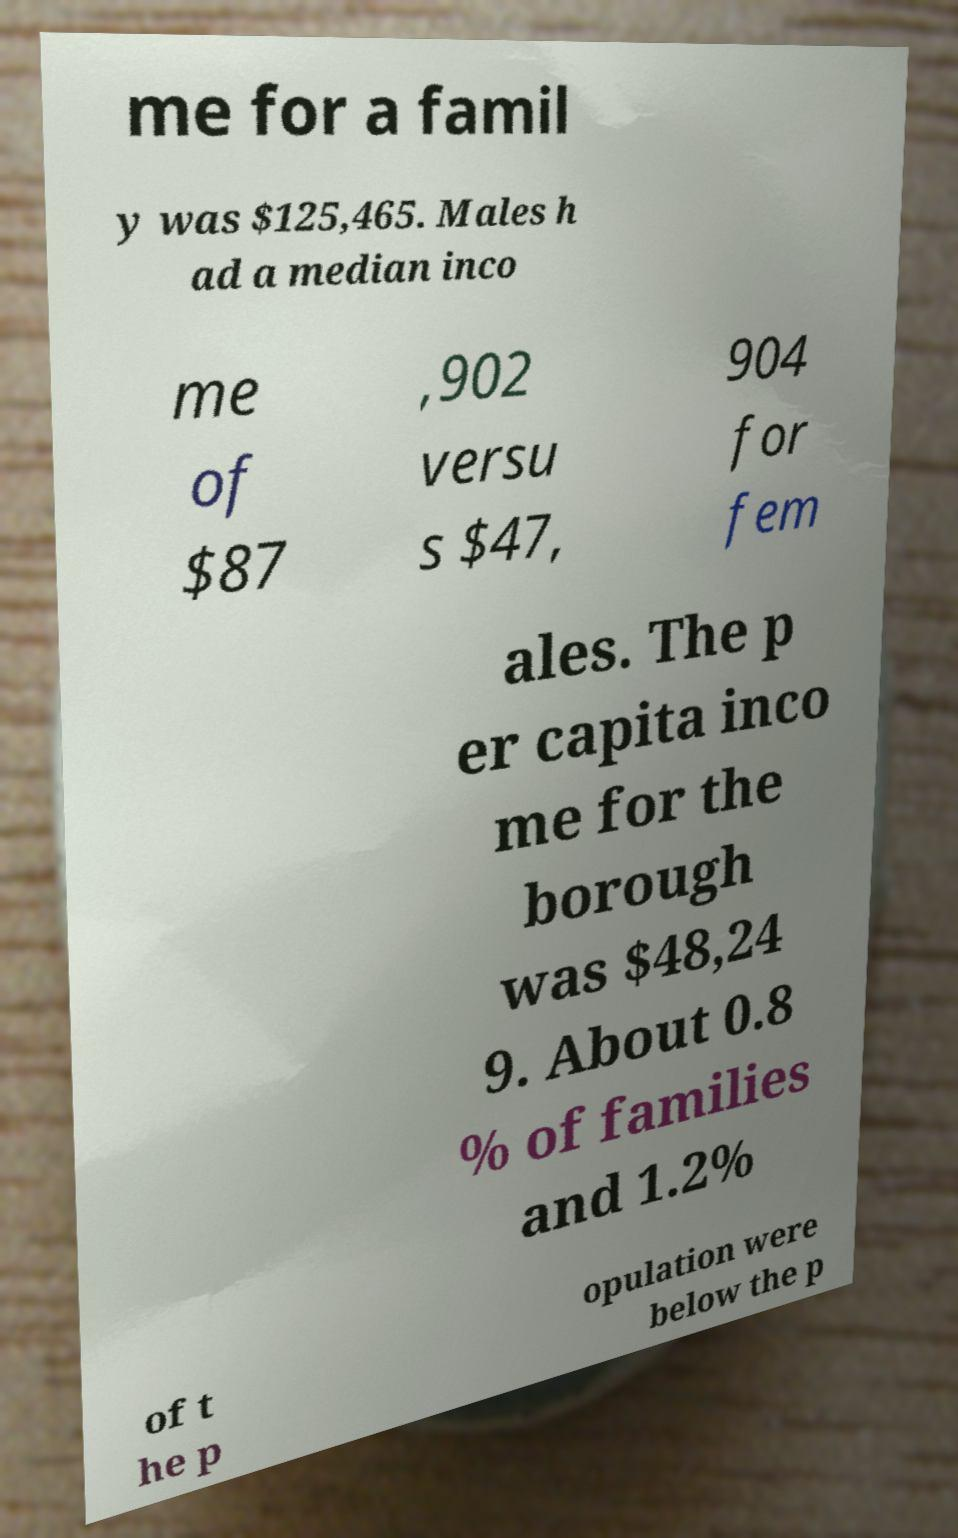Could you assist in decoding the text presented in this image and type it out clearly? me for a famil y was $125,465. Males h ad a median inco me of $87 ,902 versu s $47, 904 for fem ales. The p er capita inco me for the borough was $48,24 9. About 0.8 % of families and 1.2% of t he p opulation were below the p 